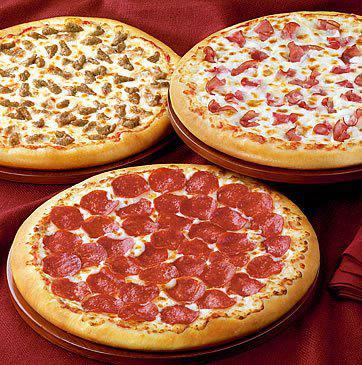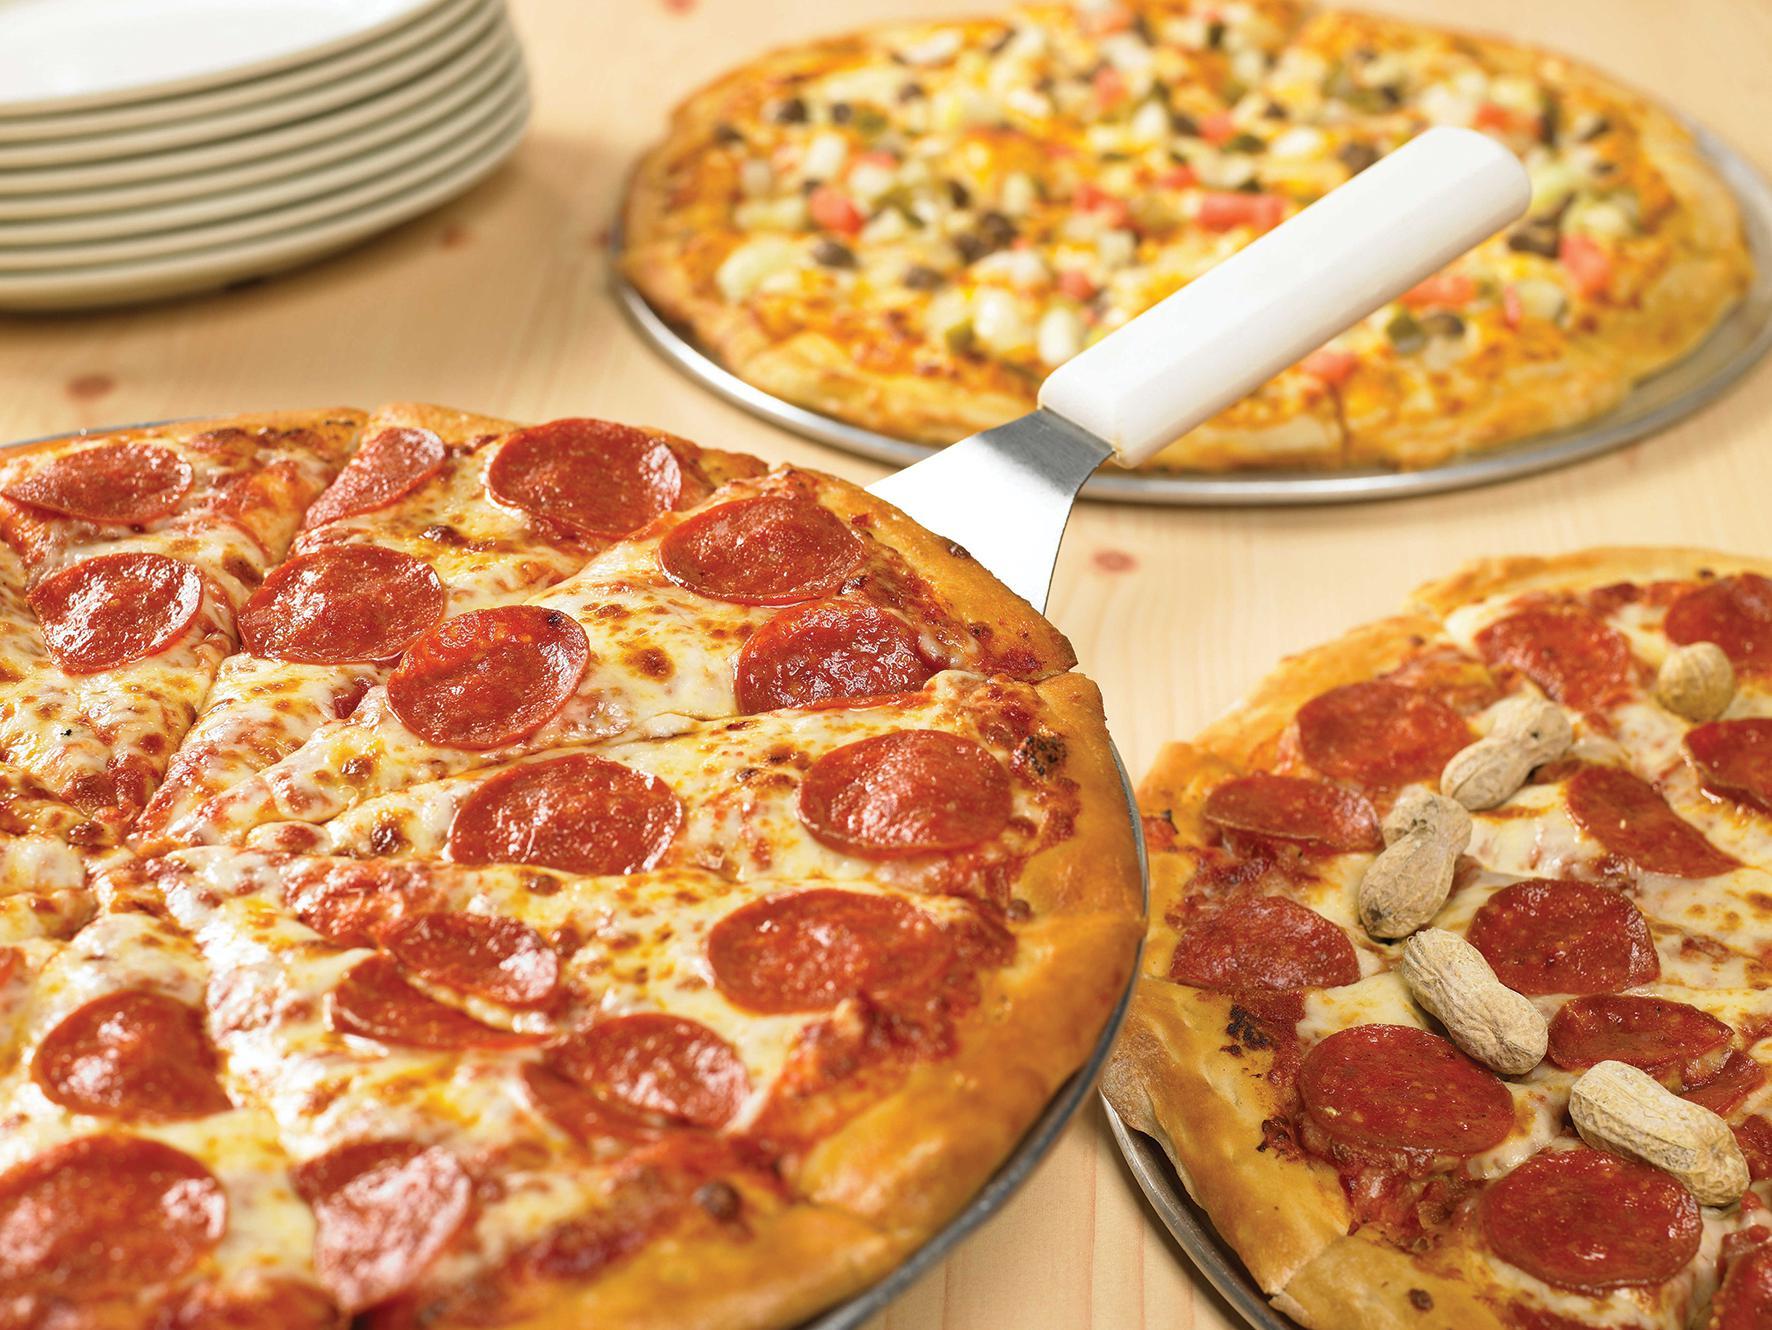The first image is the image on the left, the second image is the image on the right. Considering the images on both sides, is "The right image shows a slice of pizza lifted upward, with cheese stretching along its side, from a round pie, and the left image includes a whole round pizza." valid? Answer yes or no. No. The first image is the image on the left, the second image is the image on the right. For the images shown, is this caption "One slice is being lifted off the pizza." true? Answer yes or no. No. 